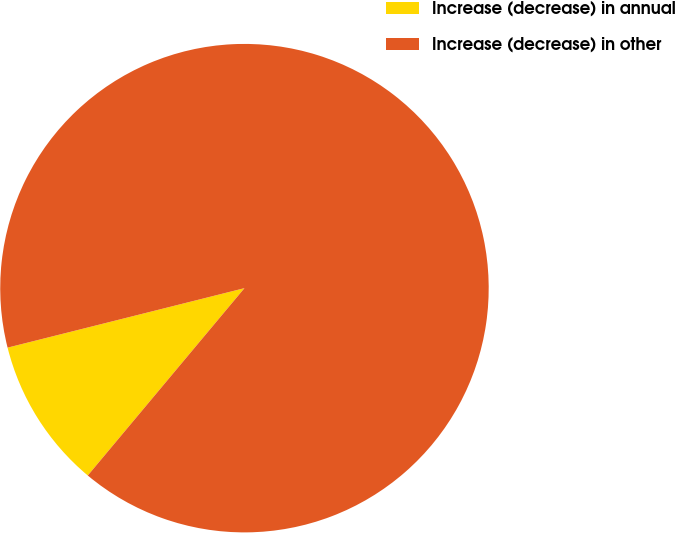Convert chart to OTSL. <chart><loc_0><loc_0><loc_500><loc_500><pie_chart><fcel>Increase (decrease) in annual<fcel>Increase (decrease) in other<nl><fcel>10.0%<fcel>90.0%<nl></chart> 